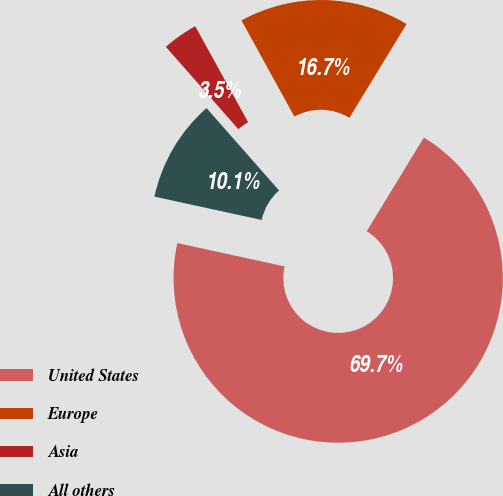<chart> <loc_0><loc_0><loc_500><loc_500><pie_chart><fcel>United States<fcel>Europe<fcel>Asia<fcel>All others<nl><fcel>69.69%<fcel>16.72%<fcel>3.48%<fcel>10.1%<nl></chart> 